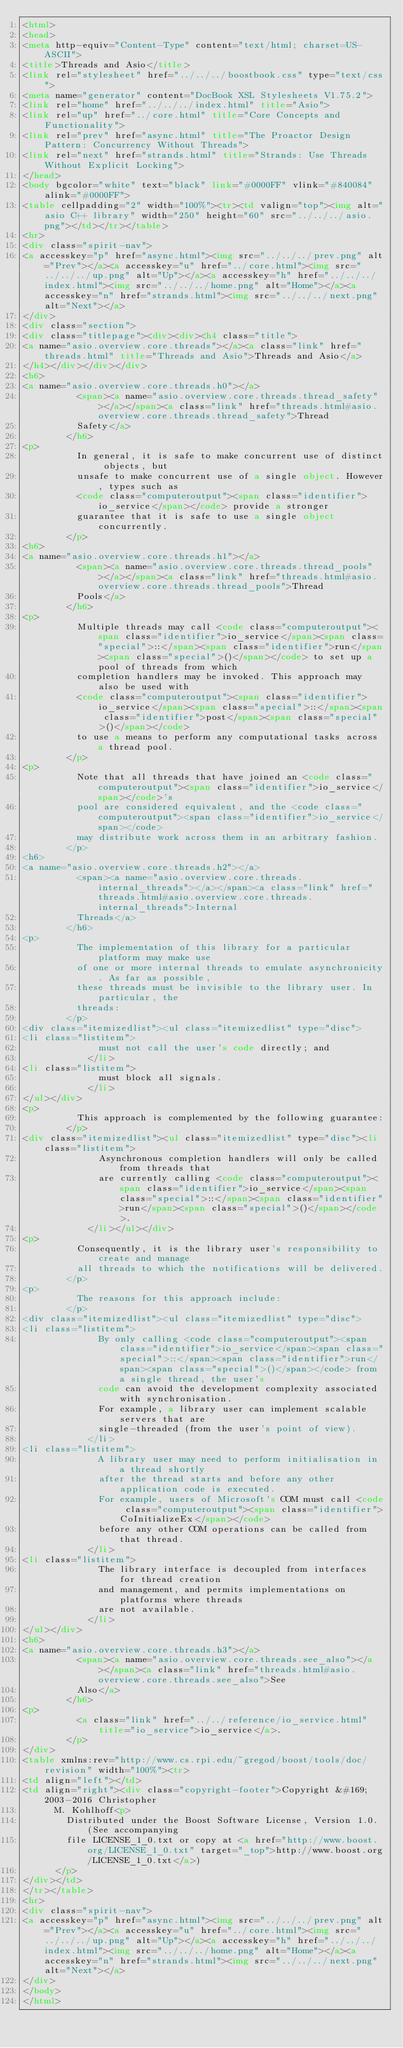<code> <loc_0><loc_0><loc_500><loc_500><_HTML_><html>
<head>
<meta http-equiv="Content-Type" content="text/html; charset=US-ASCII">
<title>Threads and Asio</title>
<link rel="stylesheet" href="../../../boostbook.css" type="text/css">
<meta name="generator" content="DocBook XSL Stylesheets V1.75.2">
<link rel="home" href="../../../index.html" title="Asio">
<link rel="up" href="../core.html" title="Core Concepts and Functionality">
<link rel="prev" href="async.html" title="The Proactor Design Pattern: Concurrency Without Threads">
<link rel="next" href="strands.html" title="Strands: Use Threads Without Explicit Locking">
</head>
<body bgcolor="white" text="black" link="#0000FF" vlink="#840084" alink="#0000FF">
<table cellpadding="2" width="100%"><tr><td valign="top"><img alt="asio C++ library" width="250" height="60" src="../../../asio.png"></td></tr></table>
<hr>
<div class="spirit-nav">
<a accesskey="p" href="async.html"><img src="../../../prev.png" alt="Prev"></a><a accesskey="u" href="../core.html"><img src="../../../up.png" alt="Up"></a><a accesskey="h" href="../../../index.html"><img src="../../../home.png" alt="Home"></a><a accesskey="n" href="strands.html"><img src="../../../next.png" alt="Next"></a>
</div>
<div class="section">
<div class="titlepage"><div><div><h4 class="title">
<a name="asio.overview.core.threads"></a><a class="link" href="threads.html" title="Threads and Asio">Threads and Asio</a>
</h4></div></div></div>
<h6>
<a name="asio.overview.core.threads.h0"></a>
          <span><a name="asio.overview.core.threads.thread_safety"></a></span><a class="link" href="threads.html#asio.overview.core.threads.thread_safety">Thread
          Safety</a>
        </h6>
<p>
          In general, it is safe to make concurrent use of distinct objects, but
          unsafe to make concurrent use of a single object. However, types such as
          <code class="computeroutput"><span class="identifier">io_service</span></code> provide a stronger
          guarantee that it is safe to use a single object concurrently.
        </p>
<h6>
<a name="asio.overview.core.threads.h1"></a>
          <span><a name="asio.overview.core.threads.thread_pools"></a></span><a class="link" href="threads.html#asio.overview.core.threads.thread_pools">Thread
          Pools</a>
        </h6>
<p>
          Multiple threads may call <code class="computeroutput"><span class="identifier">io_service</span><span class="special">::</span><span class="identifier">run</span><span class="special">()</span></code> to set up a pool of threads from which
          completion handlers may be invoked. This approach may also be used with
          <code class="computeroutput"><span class="identifier">io_service</span><span class="special">::</span><span class="identifier">post</span><span class="special">()</span></code>
          to use a means to perform any computational tasks across a thread pool.
        </p>
<p>
          Note that all threads that have joined an <code class="computeroutput"><span class="identifier">io_service</span></code>'s
          pool are considered equivalent, and the <code class="computeroutput"><span class="identifier">io_service</span></code>
          may distribute work across them in an arbitrary fashion.
        </p>
<h6>
<a name="asio.overview.core.threads.h2"></a>
          <span><a name="asio.overview.core.threads.internal_threads"></a></span><a class="link" href="threads.html#asio.overview.core.threads.internal_threads">Internal
          Threads</a>
        </h6>
<p>
          The implementation of this library for a particular platform may make use
          of one or more internal threads to emulate asynchronicity. As far as possible,
          these threads must be invisible to the library user. In particular, the
          threads:
        </p>
<div class="itemizedlist"><ul class="itemizedlist" type="disc">
<li class="listitem">
              must not call the user's code directly; and
            </li>
<li class="listitem">
              must block all signals.
            </li>
</ul></div>
<p>
          This approach is complemented by the following guarantee:
        </p>
<div class="itemizedlist"><ul class="itemizedlist" type="disc"><li class="listitem">
              Asynchronous completion handlers will only be called from threads that
              are currently calling <code class="computeroutput"><span class="identifier">io_service</span><span class="special">::</span><span class="identifier">run</span><span class="special">()</span></code>.
            </li></ul></div>
<p>
          Consequently, it is the library user's responsibility to create and manage
          all threads to which the notifications will be delivered.
        </p>
<p>
          The reasons for this approach include:
        </p>
<div class="itemizedlist"><ul class="itemizedlist" type="disc">
<li class="listitem">
              By only calling <code class="computeroutput"><span class="identifier">io_service</span><span class="special">::</span><span class="identifier">run</span><span class="special">()</span></code> from a single thread, the user's
              code can avoid the development complexity associated with synchronisation.
              For example, a library user can implement scalable servers that are
              single-threaded (from the user's point of view).
            </li>
<li class="listitem">
              A library user may need to perform initialisation in a thread shortly
              after the thread starts and before any other application code is executed.
              For example, users of Microsoft's COM must call <code class="computeroutput"><span class="identifier">CoInitializeEx</span></code>
              before any other COM operations can be called from that thread.
            </li>
<li class="listitem">
              The library interface is decoupled from interfaces for thread creation
              and management, and permits implementations on platforms where threads
              are not available.
            </li>
</ul></div>
<h6>
<a name="asio.overview.core.threads.h3"></a>
          <span><a name="asio.overview.core.threads.see_also"></a></span><a class="link" href="threads.html#asio.overview.core.threads.see_also">See
          Also</a>
        </h6>
<p>
          <a class="link" href="../../reference/io_service.html" title="io_service">io_service</a>.
        </p>
</div>
<table xmlns:rev="http://www.cs.rpi.edu/~gregod/boost/tools/doc/revision" width="100%"><tr>
<td align="left"></td>
<td align="right"><div class="copyright-footer">Copyright &#169; 2003-2016 Christopher
      M. Kohlhoff<p>
        Distributed under the Boost Software License, Version 1.0. (See accompanying
        file LICENSE_1_0.txt or copy at <a href="http://www.boost.org/LICENSE_1_0.txt" target="_top">http://www.boost.org/LICENSE_1_0.txt</a>)
      </p>
</div></td>
</tr></table>
<hr>
<div class="spirit-nav">
<a accesskey="p" href="async.html"><img src="../../../prev.png" alt="Prev"></a><a accesskey="u" href="../core.html"><img src="../../../up.png" alt="Up"></a><a accesskey="h" href="../../../index.html"><img src="../../../home.png" alt="Home"></a><a accesskey="n" href="strands.html"><img src="../../../next.png" alt="Next"></a>
</div>
</body>
</html>
</code> 